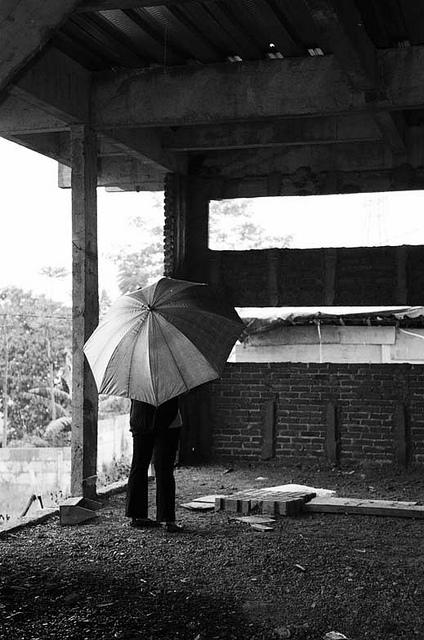Can the person remove the umbrella without getting wet at his current location?
Concise answer only. Yes. Is the floor exposed ground?
Give a very brief answer. Yes. Is the a color photo or black and white?
Quick response, please. Black and white. 